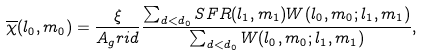Convert formula to latex. <formula><loc_0><loc_0><loc_500><loc_500>\overline { \chi } ( l _ { 0 } , m _ { 0 } ) = \frac { \xi } { A _ { g } r i d } \frac { \sum _ { d < d _ { 0 } } S F R ( l _ { 1 } , m _ { 1 } ) W ( l _ { 0 } , m _ { 0 } ; l _ { 1 } , m _ { 1 } ) } { \sum _ { d < d _ { 0 } } W ( l _ { 0 } , m _ { 0 } ; l _ { 1 } , m _ { 1 } ) } , \\</formula> 